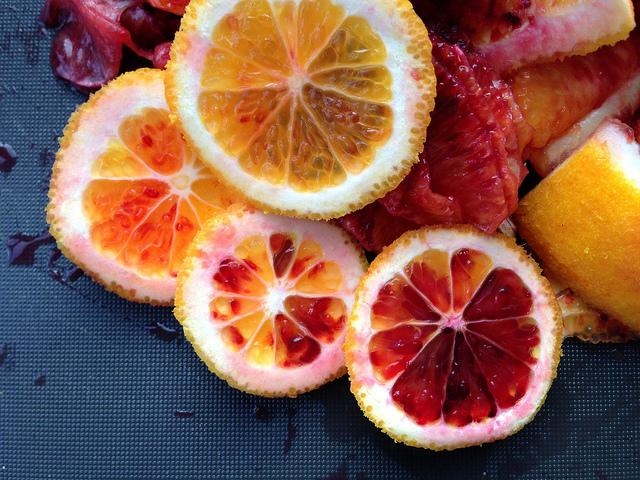Is the fruit sliced?
Concise answer only. Yes. Are these citrus fruits?
Keep it brief. Yes. What kind of oranges are these?
Be succinct. Blood. 